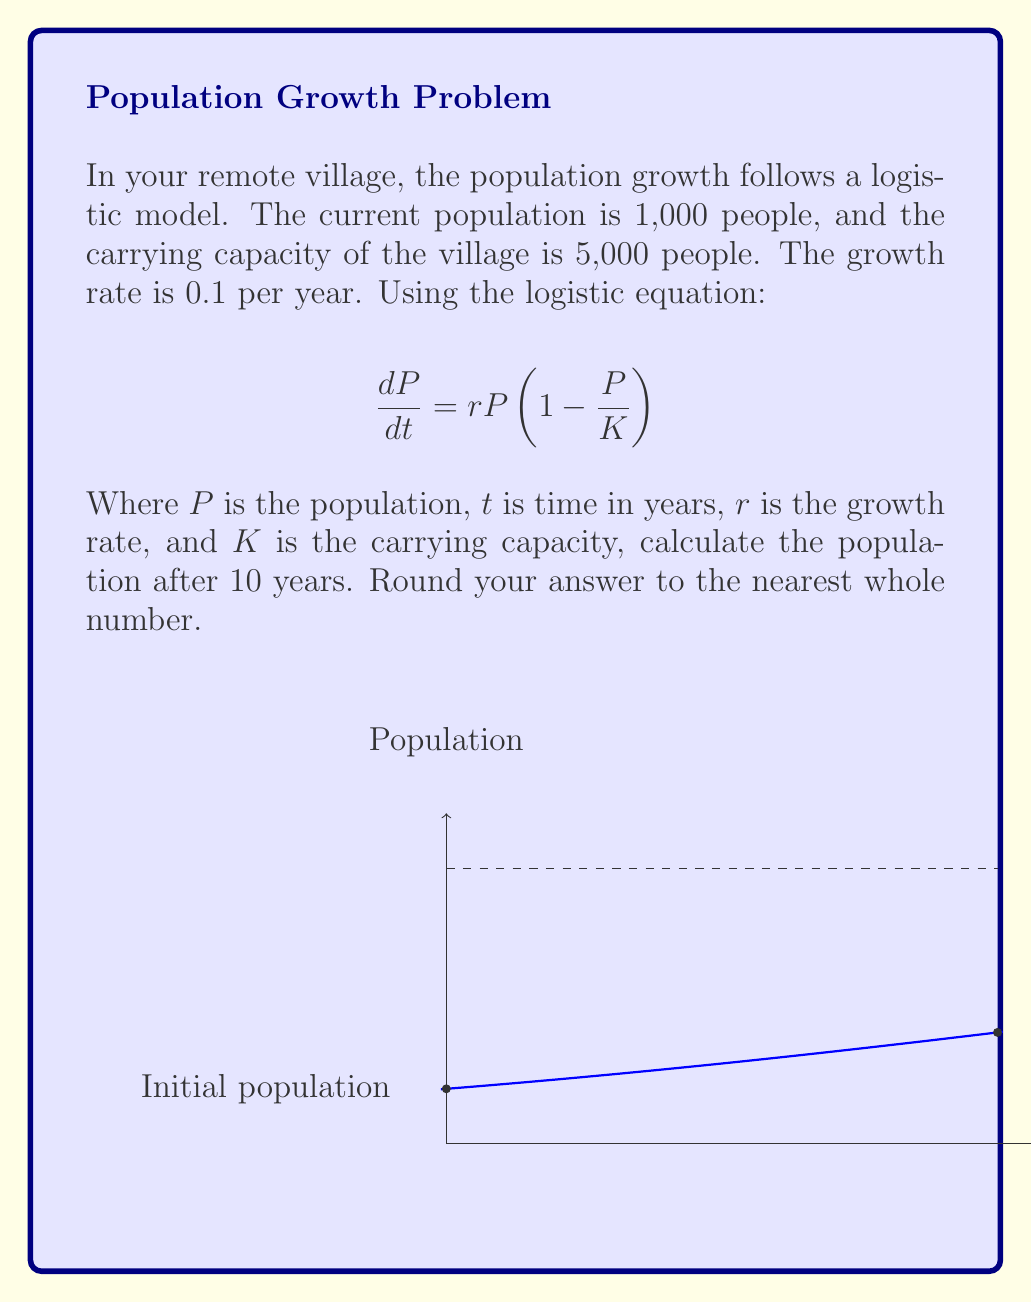Can you answer this question? Let's solve this problem step by step:

1) The logistic equation is given as:
   $$\frac{dP}{dt} = rP(1 - \frac{P}{K})$$

2) We're given:
   - Initial population, $P_0 = 1,000$
   - Carrying capacity, $K = 5,000$
   - Growth rate, $r = 0.1$
   - Time, $t = 10$ years

3) The solution to the logistic equation is:
   $$P(t) = \frac{K}{1 + (\frac{K}{P_0} - 1)e^{-rt}}$$

4) Let's substitute our values:
   $$P(10) = \frac{5000}{1 + (\frac{5000}{1000} - 1)e^{-0.1 \cdot 10}}$$

5) Simplify:
   $$P(10) = \frac{5000}{1 + 4e^{-1}}$$

6) Calculate:
   $$P(10) = \frac{5000}{1 + 4 \cdot 0.3679}$$
   $$P(10) = \frac{5000}{2.4716}$$
   $$P(10) = 2022.98$$

7) Rounding to the nearest whole number:
   $$P(10) \approx 2023$$
Answer: 2023 people 